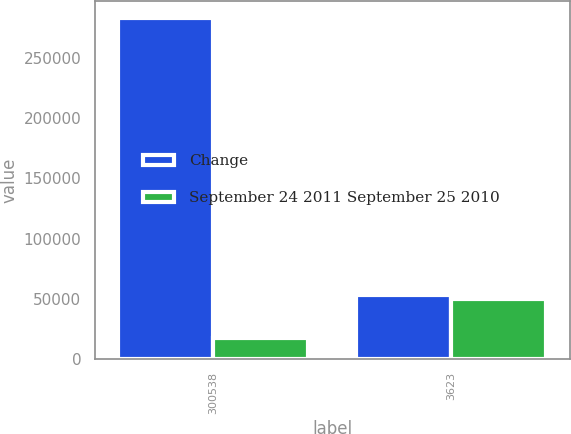<chart> <loc_0><loc_0><loc_500><loc_500><stacked_bar_chart><ecel><fcel>300538<fcel>3623<nl><fcel>Change<fcel>283142<fcel>53071<nl><fcel>September 24 2011 September 25 2010<fcel>17396<fcel>49448<nl></chart> 